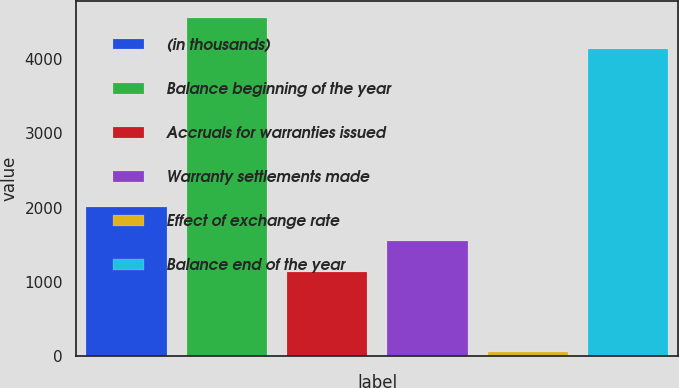Convert chart. <chart><loc_0><loc_0><loc_500><loc_500><bar_chart><fcel>(in thousands)<fcel>Balance beginning of the year<fcel>Accruals for warranties issued<fcel>Warranty settlements made<fcel>Effect of exchange rate<fcel>Balance end of the year<nl><fcel>2009<fcel>4562.3<fcel>1129<fcel>1550.3<fcel>47<fcel>4141<nl></chart> 